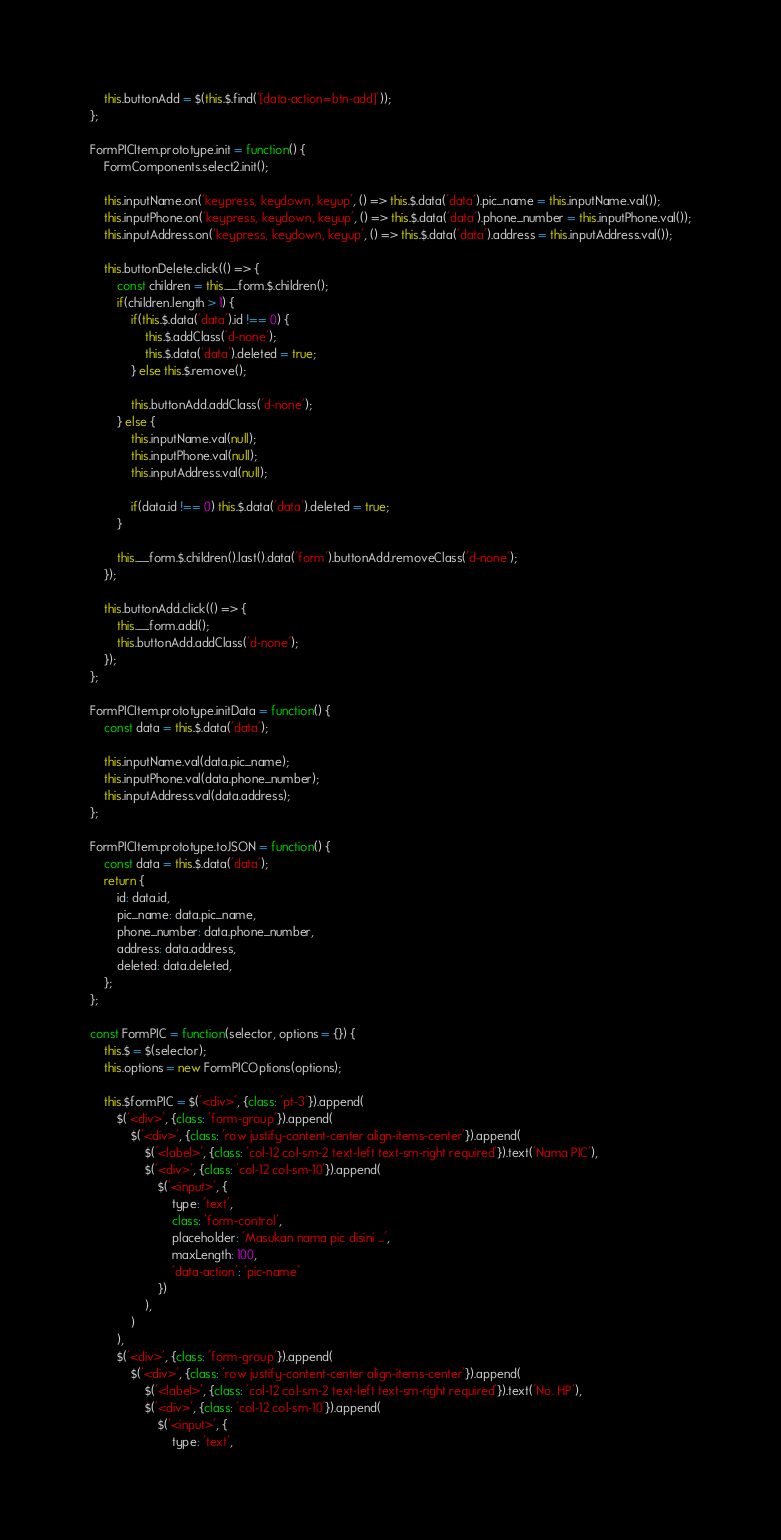Convert code to text. <code><loc_0><loc_0><loc_500><loc_500><_JavaScript_>    this.buttonAdd = $(this.$.find('[data-action=btn-add]'));
};

FormPICItem.prototype.init = function() {
    FormComponents.select2.init();

    this.inputName.on('keypress, keydown, keyup', () => this.$.data('data').pic_name = this.inputName.val());
    this.inputPhone.on('keypress, keydown, keyup', () => this.$.data('data').phone_number = this.inputPhone.val());
    this.inputAddress.on('keypress, keydown, keyup', () => this.$.data('data').address = this.inputAddress.val());

    this.buttonDelete.click(() => {
        const children = this.__form.$.children();
        if(children.length > 1) {
            if(this.$.data('data').id !== 0) {
                this.$.addClass('d-none');
                this.$.data('data').deleted = true;
            } else this.$.remove();

            this.buttonAdd.addClass('d-none');
        } else {
            this.inputName.val(null);
            this.inputPhone.val(null);
            this.inputAddress.val(null);

            if(data.id !== 0) this.$.data('data').deleted = true;
        }

        this.__form.$.children().last().data('form').buttonAdd.removeClass('d-none');
    });

    this.buttonAdd.click(() => {
        this.__form.add();
        this.buttonAdd.addClass('d-none');
    });
};

FormPICItem.prototype.initData = function() {
    const data = this.$.data('data');

    this.inputName.val(data.pic_name);
    this.inputPhone.val(data.phone_number);
    this.inputAddress.val(data.address);
};

FormPICItem.prototype.toJSON = function() {
    const data = this.$.data('data');
    return {
        id: data.id,
        pic_name: data.pic_name,
        phone_number: data.phone_number,
        address: data.address,
        deleted: data.deleted,
    };
};

const FormPIC = function(selector, options = {}) {
    this.$ = $(selector);
    this.options = new FormPICOptions(options);

    this.$formPIC = $('<div>', {class: 'pt-3'}).append(
        $('<div>', {class: 'form-group'}).append(
            $('<div>', {class: 'row justify-content-center align-items-center'}).append(
                $('<label>', {class: 'col-12 col-sm-2 text-left text-sm-right required'}).text('Nama PIC'),
                $('<div>', {class: 'col-12 col-sm-10'}).append(
                    $('<input>', {
                        type: 'text',
                        class: 'form-control',
                        placeholder: 'Masukan nama pic disini ...',
                        maxLength: 100,
                        'data-action': 'pic-name'
                    })
                ),
            )
        ),
        $('<div>', {class: 'form-group'}).append(
            $('<div>', {class: 'row justify-content-center align-items-center'}).append(
                $('<label>', {class: 'col-12 col-sm-2 text-left text-sm-right required'}).text('No. HP'),
                $('<div>', {class: 'col-12 col-sm-10'}).append(
                    $('<input>', {
                        type: 'text',</code> 